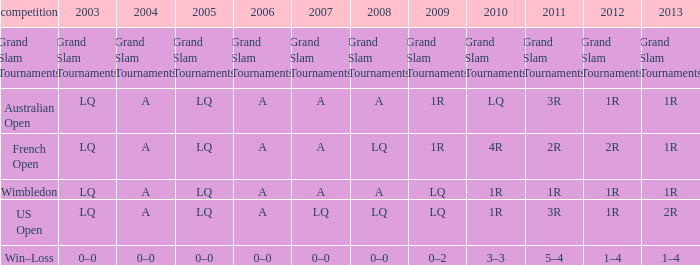Which year has a 2003 of lq? 1R, 1R, LQ, LQ. 